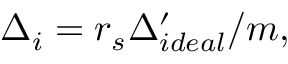<formula> <loc_0><loc_0><loc_500><loc_500>\Delta _ { i } = r _ { s } \Delta _ { i d e a l } ^ { \prime } / m ,</formula> 